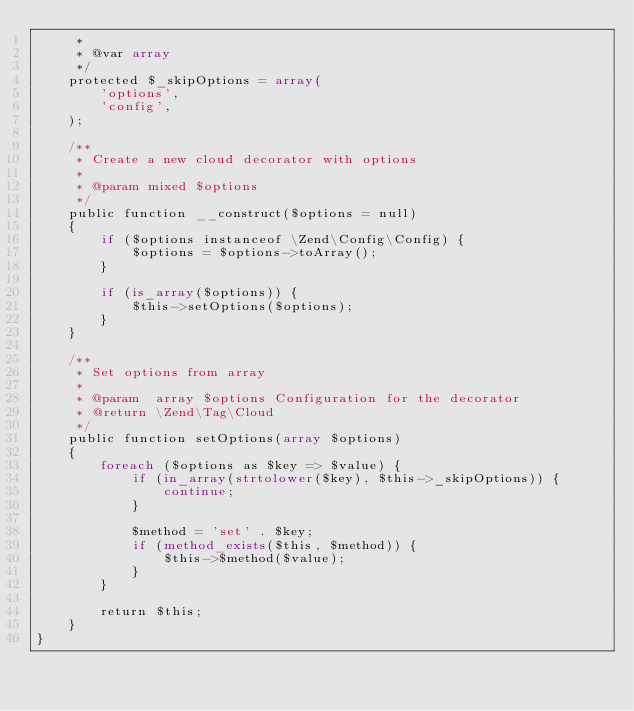<code> <loc_0><loc_0><loc_500><loc_500><_PHP_>     *
     * @var array
     */
    protected $_skipOptions = array(
        'options',
        'config',
    );

    /**
     * Create a new cloud decorator with options
     *
     * @param mixed $options
     */
    public function __construct($options = null)
    {
        if ($options instanceof \Zend\Config\Config) {
            $options = $options->toArray();
        }

        if (is_array($options)) {
            $this->setOptions($options);
        }
    }

    /**
     * Set options from array
     *
     * @param  array $options Configuration for the decorator
     * @return \Zend\Tag\Cloud
     */
    public function setOptions(array $options)
    {
        foreach ($options as $key => $value) {
            if (in_array(strtolower($key), $this->_skipOptions)) {
                continue;
            }

            $method = 'set' . $key;
            if (method_exists($this, $method)) {
                $this->$method($value);
            }
        }

        return $this;
    }
}
</code> 